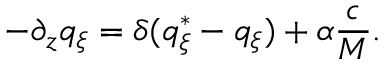Convert formula to latex. <formula><loc_0><loc_0><loc_500><loc_500>- \partial _ { z } q _ { \xi } = \delta ( q _ { \xi } ^ { * } - q _ { \xi } ) + \alpha \frac { c } { M } .</formula> 